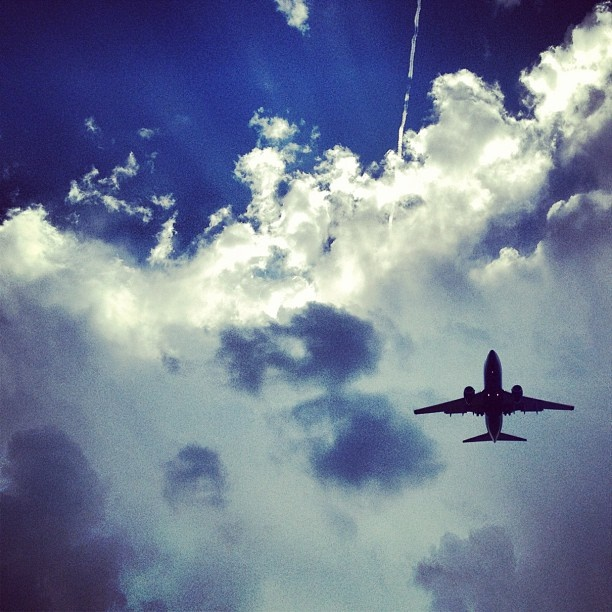Describe the objects in this image and their specific colors. I can see a airplane in navy, purple, and darkgray tones in this image. 